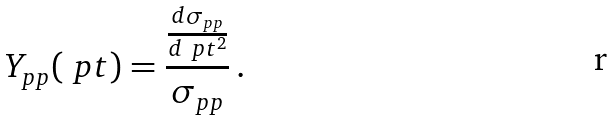Convert formula to latex. <formula><loc_0><loc_0><loc_500><loc_500>Y _ { p p } ( \ p t ) = \frac { \frac { d \sigma _ { p p } } { d \ p t ^ { 2 } } } { \sigma _ { p p } } \, .</formula> 